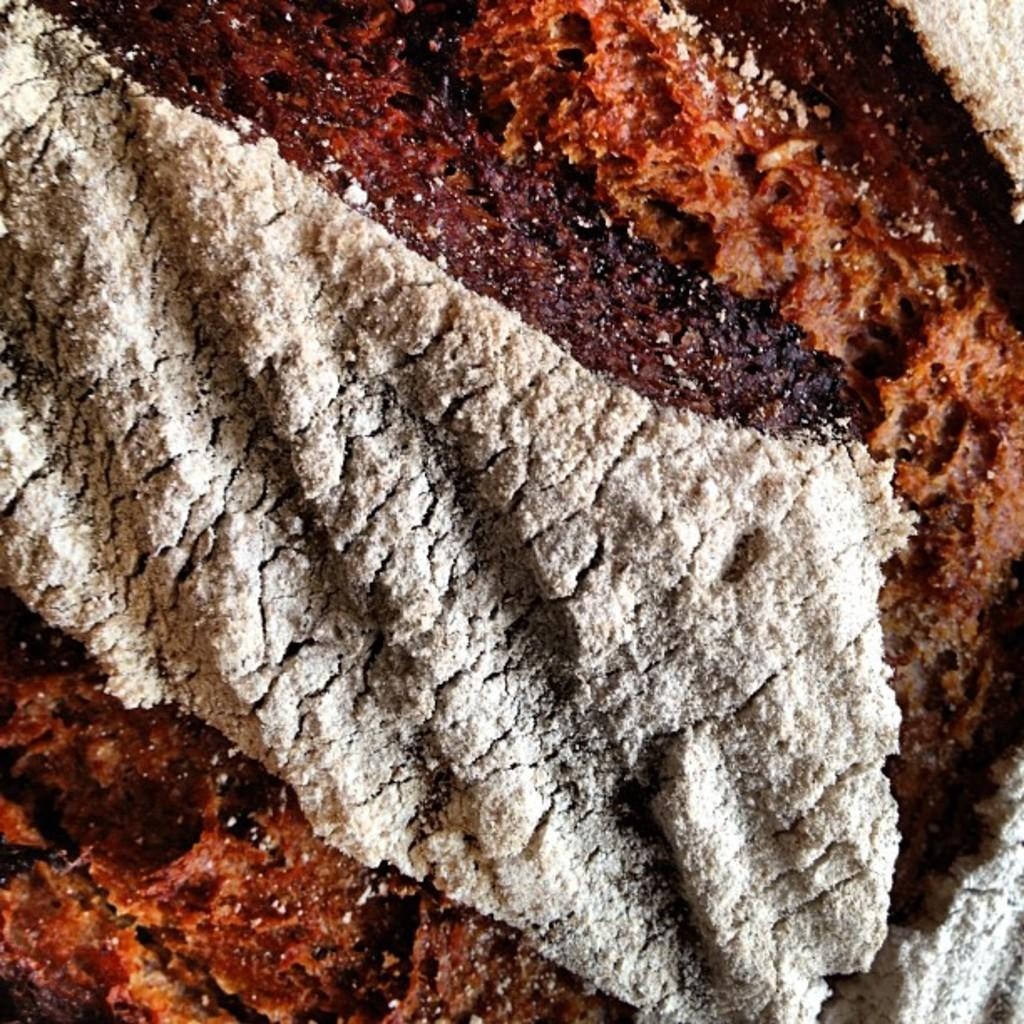What is the main subject of the image? There is a cake in the image. What can be observed about the top layer of the cake? The top layer of the cake is white in color. What type of plants are growing on the cake in the image? There are no plants visible on the cake in the image. 